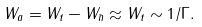Convert formula to latex. <formula><loc_0><loc_0><loc_500><loc_500>W _ { a } = W _ { t } - W _ { \bar { n } } \approx W _ { t } \sim 1 / \Gamma .</formula> 